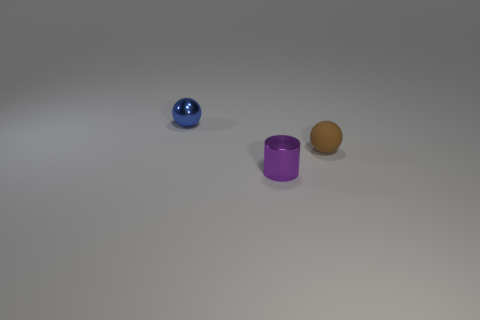Add 3 tiny purple metallic things. How many objects exist? 6 Subtract all brown spheres. How many spheres are left? 1 Subtract all cylinders. How many objects are left? 2 Subtract 1 cylinders. How many cylinders are left? 0 Subtract all brown cylinders. Subtract all green blocks. How many cylinders are left? 1 Subtract all small purple blocks. Subtract all blue balls. How many objects are left? 2 Add 3 small purple cylinders. How many small purple cylinders are left? 4 Add 1 gray rubber objects. How many gray rubber objects exist? 1 Subtract 0 green blocks. How many objects are left? 3 